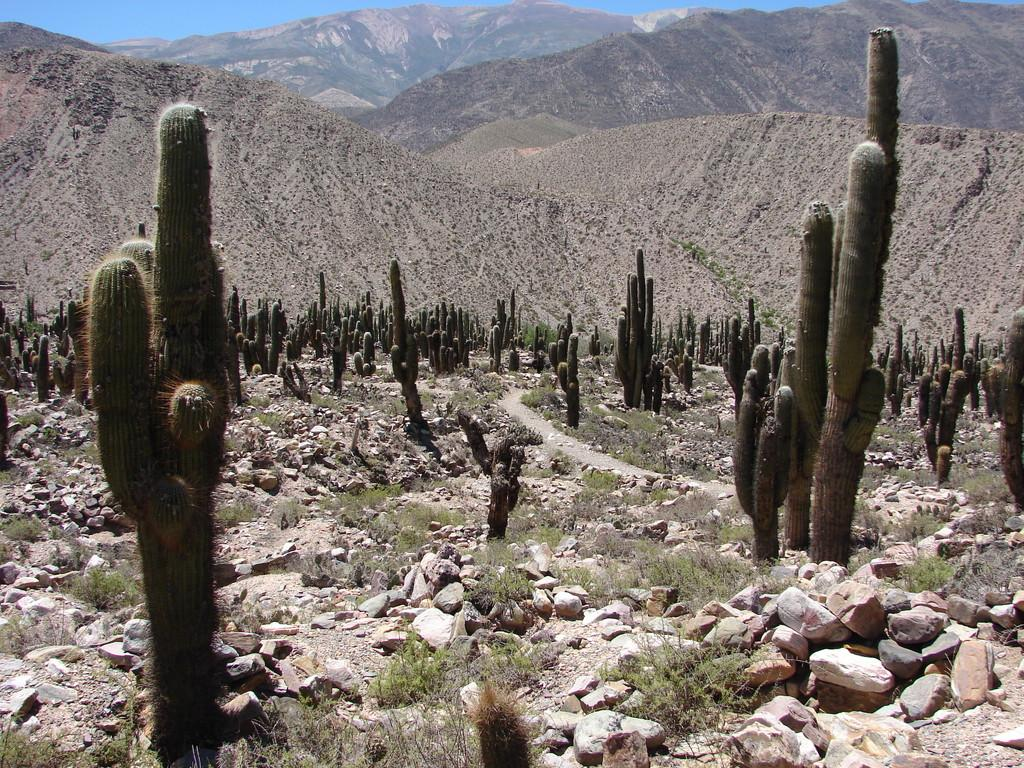What type of plants are in the image? There are cactus plants in the image. What else can be seen at the bottom of the image? There are rocks at the bottom of the image. What is visible in the background of the image? There are mountains and the sky in the background of the image. How many clocks can be seen hanging on the cactus plants in the image? There are no clocks present in the image; it features cactus plants, rocks, mountains, and the sky. What type of button can be seen on the cactus plants in the image? There are no buttons present on the cactus plants in the image. 